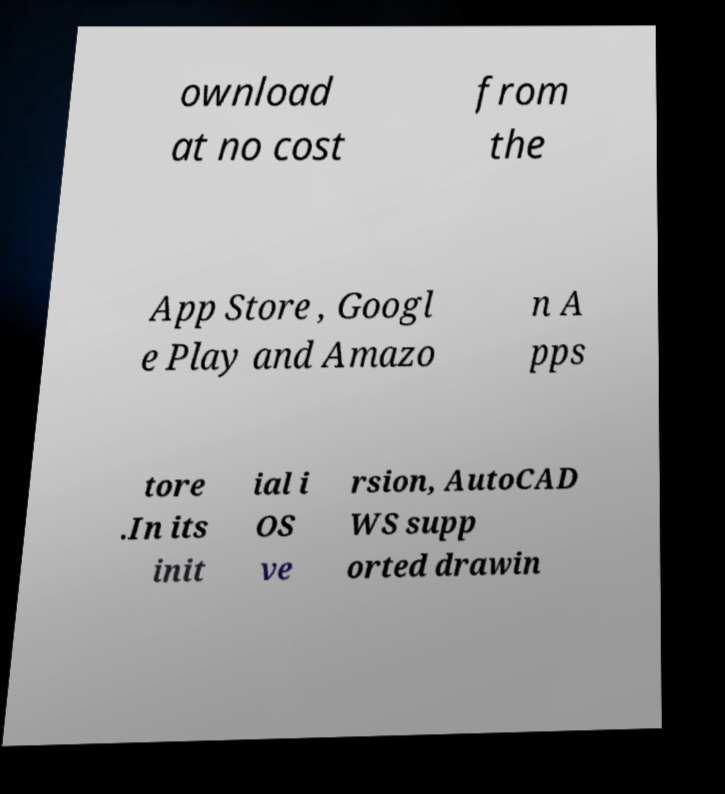Please read and relay the text visible in this image. What does it say? ownload at no cost from the App Store , Googl e Play and Amazo n A pps tore .In its init ial i OS ve rsion, AutoCAD WS supp orted drawin 